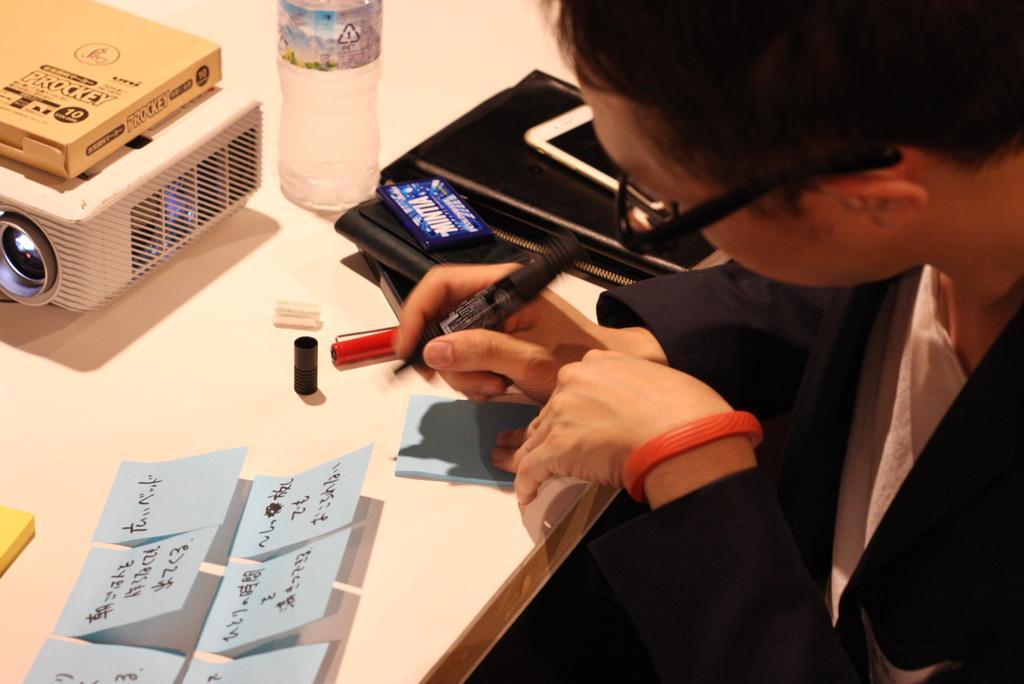In one or two sentences, can you explain what this image depicts? In this image on the right side, I can see a person. I can also see objects on the table. 